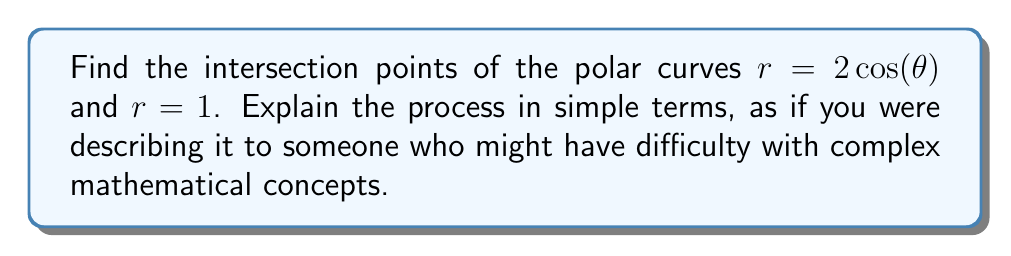Give your solution to this math problem. Let's approach this step-by-step:

1) First, we need to understand what these equations mean:
   - $r = 2\cos(\theta)$ is a circle that passes through the origin
   - $r = 1$ is a circle centered at the origin with radius 1

2) To find where these curves intersect, we set the equations equal to each other:

   $2\cos(\theta) = 1$

3) Now, we solve this equation for $\theta$:
   
   $\cos(\theta) = \frac{1}{2}$

4) This might be a bit tricky, but remember that $\cos(\theta) = \frac{1}{2}$ occurs when $\theta = \frac{\pi}{3}$ or $\theta = -\frac{\pi}{3}$ (or 60° and -60° in degrees).

5) Now that we know the angles, we can find the $r$ values. We can use either equation, let's use $r = 1$:

   For $\theta = \frac{\pi}{3}$: $r = 1$
   For $\theta = -\frac{\pi}{3}$: $r = 1$

6) In polar coordinates, we write points as $(r, \theta)$, so our intersection points are:

   $\left(1, \frac{\pi}{3}\right)$ and $\left(1, -\frac{\pi}{3}\right)$

7) If we wanted to convert these to Cartesian coordinates (x,y), we could use:
   $x = r\cos(\theta)$ and $y = r\sin(\theta)$

   For both points: 
   $x = 1 \cdot \cos(\frac{\pi}{3}) = \frac{1}{2}$
   $y = \pm(1 \cdot \sin(\frac{\pi}{3})) = \pm\frac{\sqrt{3}}{2}$

   So in (x,y) form, the points are $(\frac{1}{2}, \frac{\sqrt{3}}{2})$ and $(\frac{1}{2}, -\frac{\sqrt{3}}{2})$

[asy]
import geometry;

size(200);

draw(circle((0,0),1), blue);
draw(circle((1,0),1), red);

dot((1/2,sqrt(3)/2), green);
dot((1/2,-sqrt(3)/2), green);

label("r = 1", (0.3,1), blue);
label("r = 2cos(θ)", (1.7,0.3), red);

draw((-2,0)--(2,0), arrow=Arrow);
draw((0,-2)--(0,2), arrow=Arrow);
[/asy]
Answer: The intersection points are $\left(1, \frac{\pi}{3}\right)$ and $\left(1, -\frac{\pi}{3}\right)$ in polar coordinates, or $(\frac{1}{2}, \frac{\sqrt{3}}{2})$ and $(\frac{1}{2}, -\frac{\sqrt{3}}{2})$ in Cartesian coordinates. 